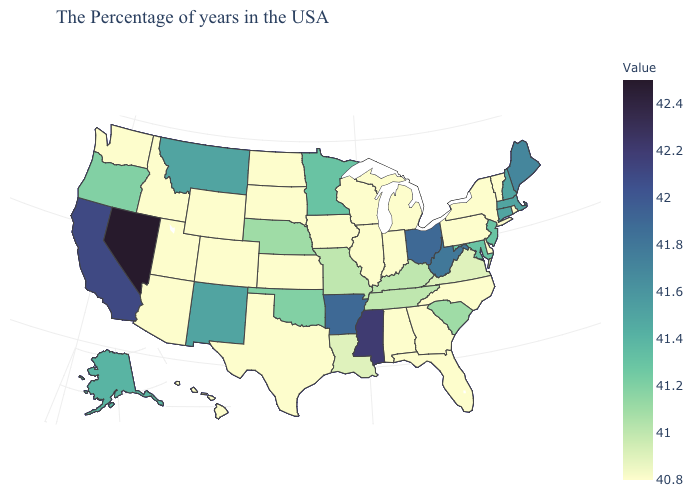Does the map have missing data?
Give a very brief answer. No. Which states have the highest value in the USA?
Quick response, please. Nevada. Which states have the lowest value in the Northeast?
Write a very short answer. Rhode Island, Vermont, New York, Pennsylvania. Does Kansas have the lowest value in the USA?
Write a very short answer. Yes. Among the states that border Arkansas , which have the highest value?
Give a very brief answer. Mississippi. Which states have the lowest value in the Northeast?
Write a very short answer. Rhode Island, Vermont, New York, Pennsylvania. 